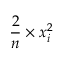Convert formula to latex. <formula><loc_0><loc_0><loc_500><loc_500>{ \frac { 2 } { n } } \times x _ { i } ^ { 2 }</formula> 